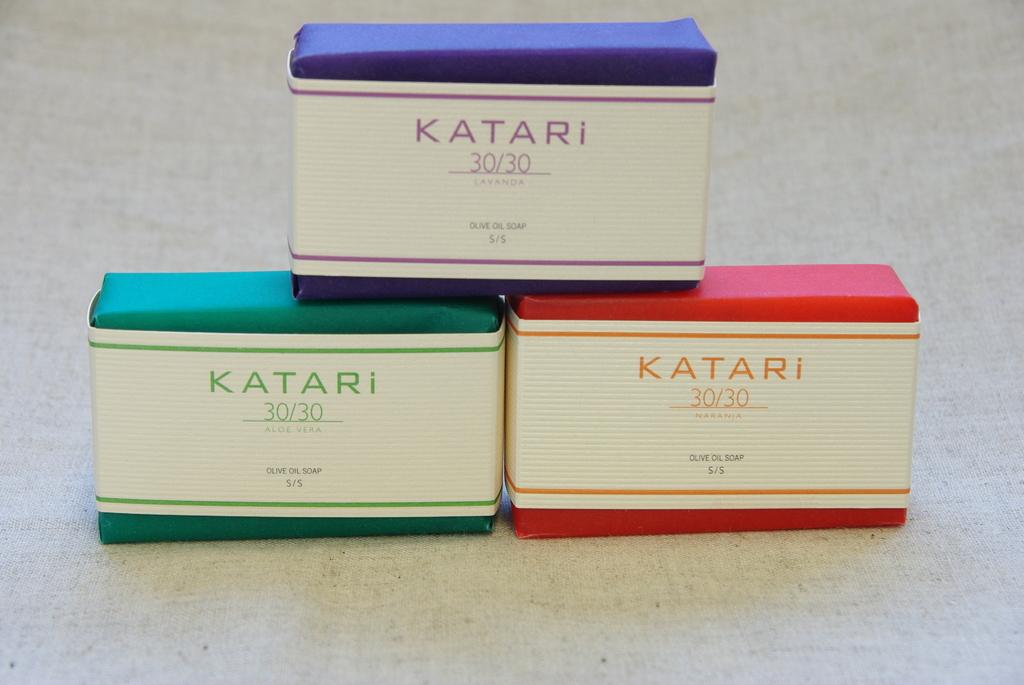What brand is all 3 boxes?
Make the answer very short. Katari. According to all three boxes, what is the main ingredient of these soaps?
Keep it short and to the point. Olive oil. 